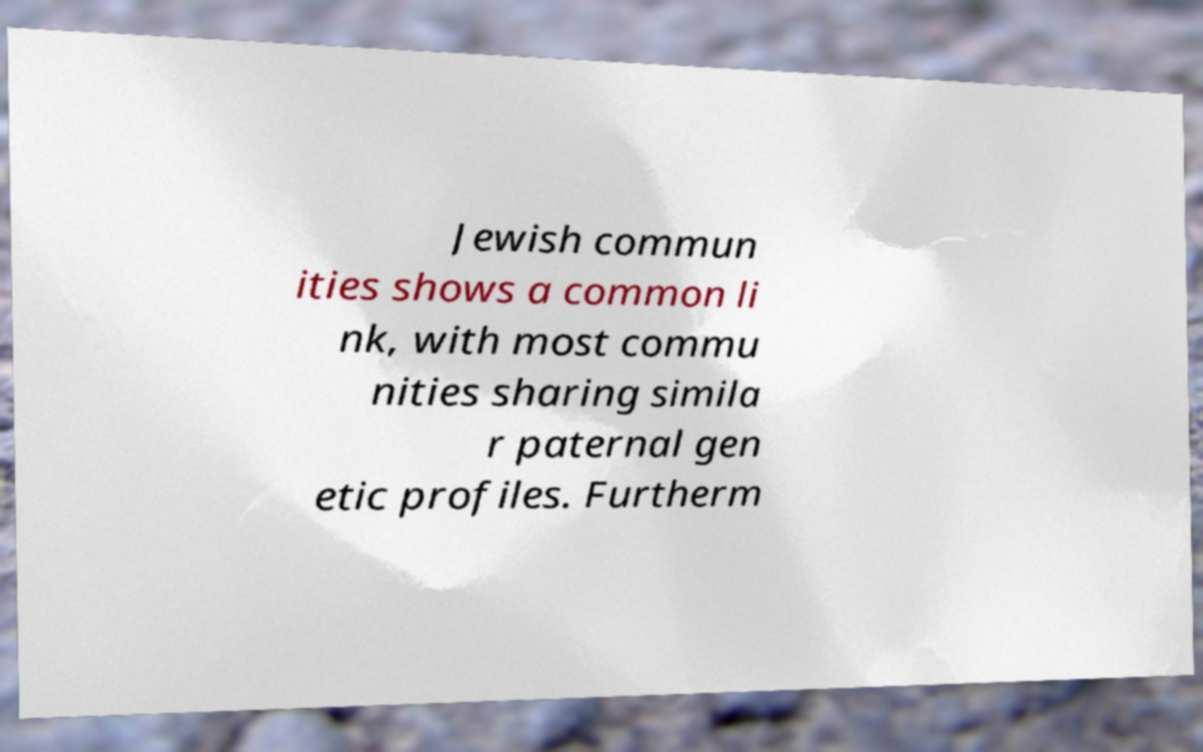For documentation purposes, I need the text within this image transcribed. Could you provide that? Jewish commun ities shows a common li nk, with most commu nities sharing simila r paternal gen etic profiles. Furtherm 